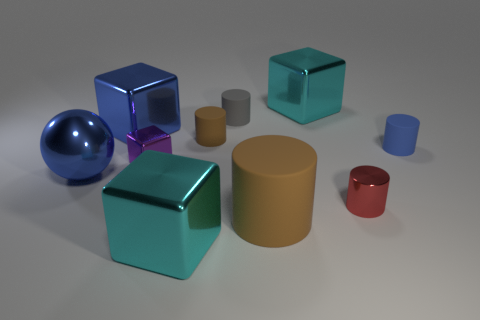There is a metal cylinder in front of the large shiny thing that is right of the cyan shiny object left of the big brown thing; what is its size?
Provide a succinct answer. Small. There is a big object that is the same shape as the tiny red object; what is its material?
Your answer should be very brief. Rubber. What size is the cylinder that is behind the large blue object behind the tiny metal block?
Your answer should be compact. Small. What is the color of the tiny metal cylinder?
Make the answer very short. Red. There is a cyan cube that is behind the large brown cylinder; how many small metallic objects are behind it?
Offer a very short reply. 0. There is a big cyan metal object that is left of the tiny gray object; are there any large metal cubes in front of it?
Your response must be concise. No. There is a small red shiny thing; are there any large cylinders behind it?
Your answer should be very brief. No. Do the matte thing in front of the small purple metallic cube and the blue rubber object have the same shape?
Offer a terse response. Yes. How many large brown things have the same shape as the tiny red metal object?
Your answer should be very brief. 1. Are there any large cyan objects that have the same material as the small purple thing?
Your answer should be compact. Yes. 